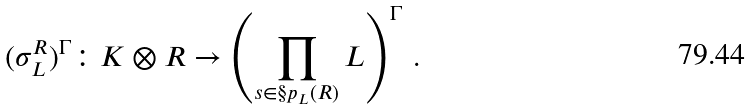Convert formula to latex. <formula><loc_0><loc_0><loc_500><loc_500>( \sigma ^ { R } _ { L } ) ^ { \Gamma } \colon K \otimes R \to \left ( \prod _ { s \in \S p _ { L } ( R ) } L \right ) ^ { \Gamma } \, .</formula> 